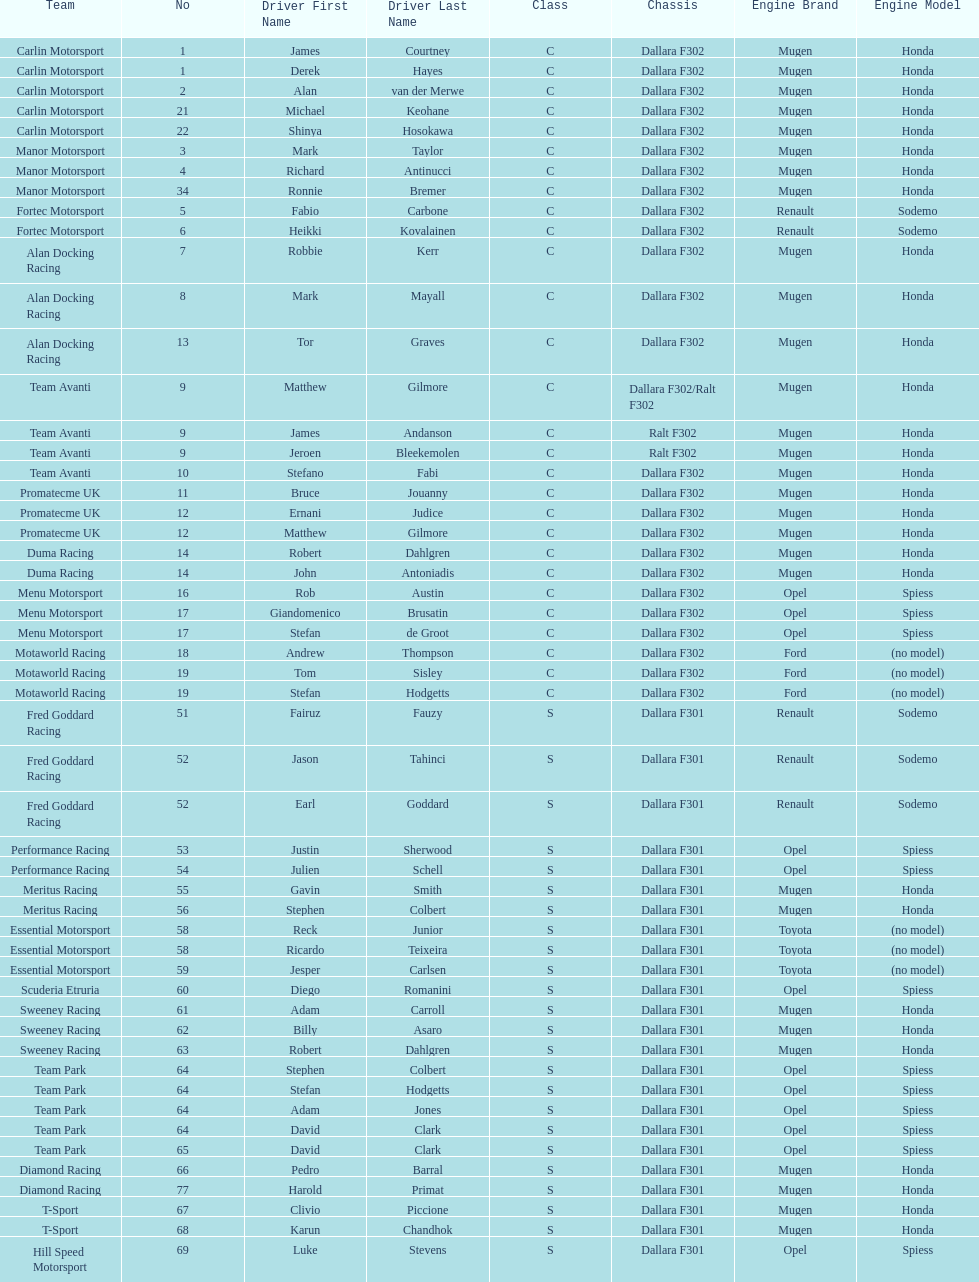Which engine was used the most by teams this season? Mugen-Honda. 